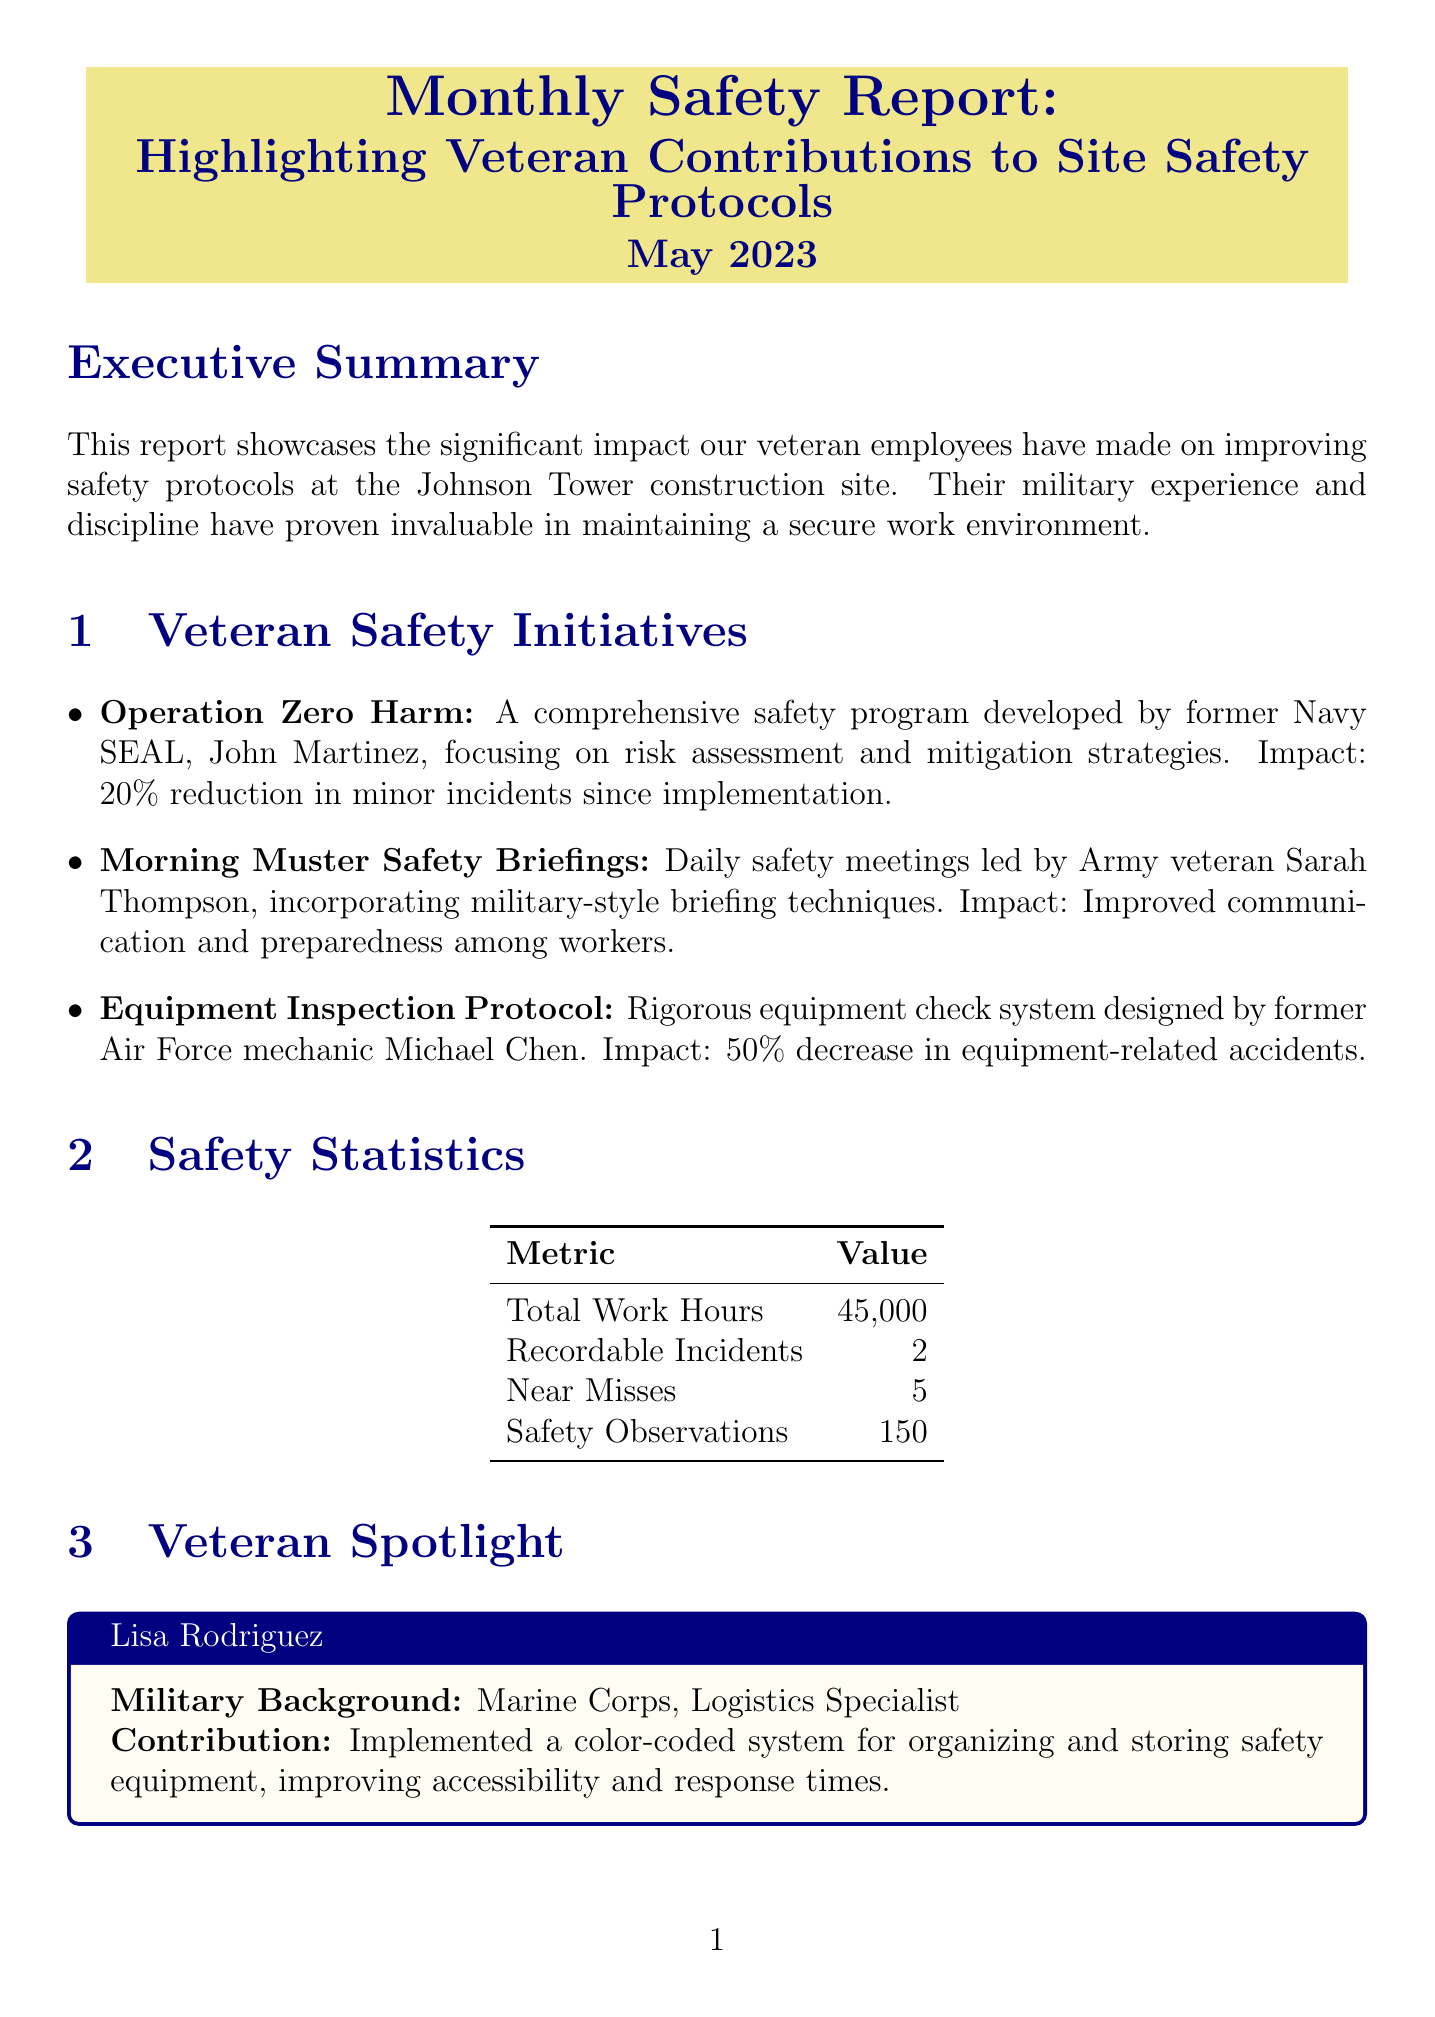what is the report title? The report title is mentioned at the beginning of the document in a highlighted box.
Answer: Monthly Safety Report: Highlighting Veteran Contributions to Site Safety Protocols who developed the "Operation Zero Harm" program? The document specifies that a former Navy SEAL developed this program.
Answer: John Martinez how many recordable incidents were reported? The total number of recordable incidents is provided in the safety statistics section.
Answer: 2 what is Lisa Rodriguez's military background? The document provides specific information about her military service in the veteran spotlight section.
Answer: Marine Corps, Logistics Specialist what was the impact of the Equipment Inspection Protocol? The impact is stated clearly in the description of the initiative regarding equipment-related accidents.
Answer: 50% decrease in equipment-related accidents who is leading the upcoming Virtual Reality Safety Simulations? The document lists the lead individual for this initiative.
Answer: Robert Turner how many participants were in the Hazard Recognition and Reporting training program? The number of participants is provided in the safety training programs section.
Answer: 40 what is the primary goal of the Peer Safety Mentorship Program? The document outlines the purpose of this upcoming initiative.
Answer: Reinforce safety culture what type of safety initiative is "Combat Lifesaver Skills for Construction"? The document describes this initiative in terms of its adaptation for a specific context.
Answer: Military first-aid techniques for construction site emergencies 